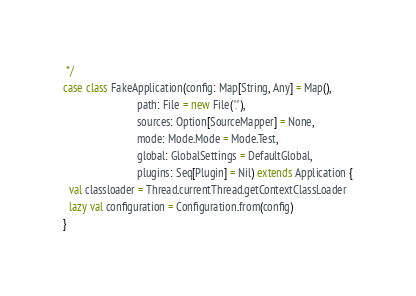Convert code to text. <code><loc_0><loc_0><loc_500><loc_500><_Scala_> */
case class FakeApplication(config: Map[String, Any] = Map(),
                           path: File = new File("."),
                           sources: Option[SourceMapper] = None,
                           mode: Mode.Mode = Mode.Test,
                           global: GlobalSettings = DefaultGlobal,
                           plugins: Seq[Plugin] = Nil) extends Application {
  val classloader = Thread.currentThread.getContextClassLoader
  lazy val configuration = Configuration.from(config)
}
</code> 